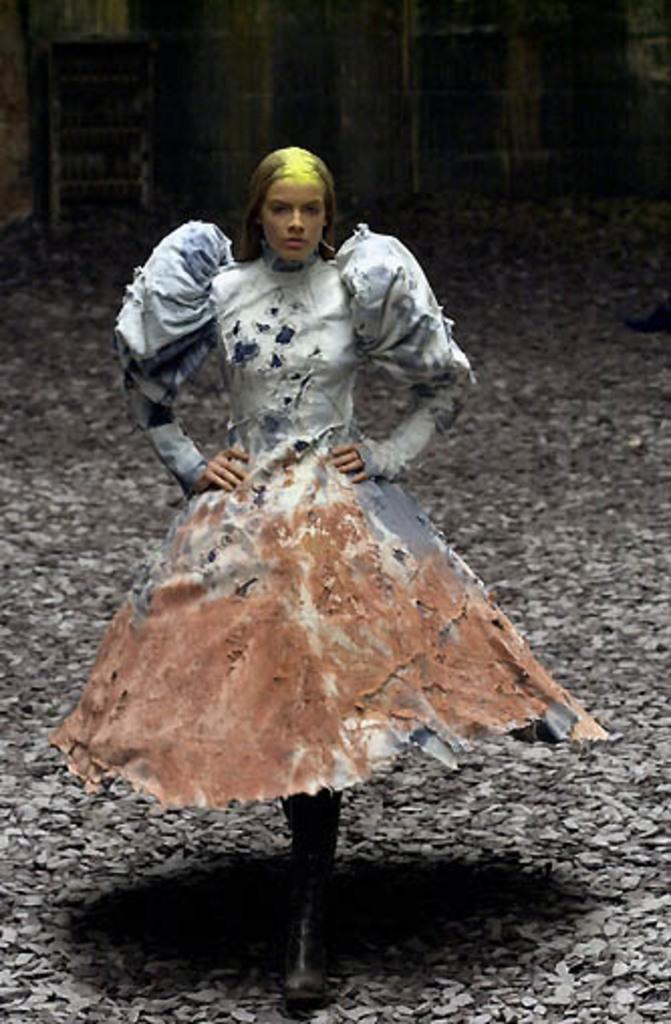Who is present in the image? There is a woman in the image. What is the woman wearing? The woman is wearing a fancy dress. Can you describe the background of the image? The background of the image is blurred. What type of meeting is taking place in the image? There is no meeting present in the image; it only features a woman wearing a fancy dress with a blurred background. How many cows can be seen in the image? There are no cows present in the image. 